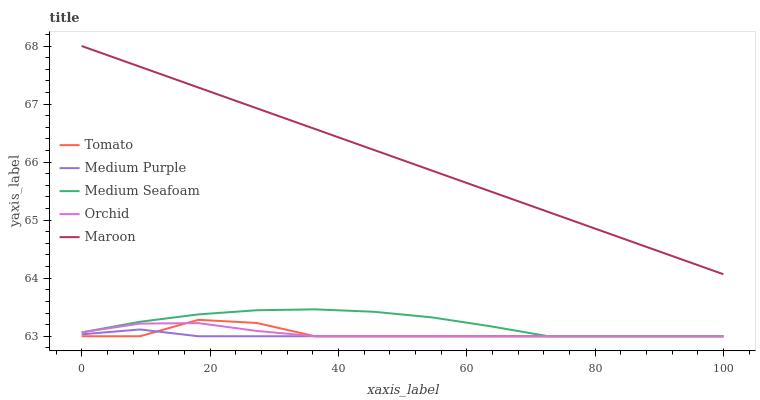Does Medium Seafoam have the minimum area under the curve?
Answer yes or no. No. Does Medium Seafoam have the maximum area under the curve?
Answer yes or no. No. Is Medium Purple the smoothest?
Answer yes or no. No. Is Medium Purple the roughest?
Answer yes or no. No. Does Maroon have the lowest value?
Answer yes or no. No. Does Medium Seafoam have the highest value?
Answer yes or no. No. Is Medium Seafoam less than Maroon?
Answer yes or no. Yes. Is Maroon greater than Medium Purple?
Answer yes or no. Yes. Does Medium Seafoam intersect Maroon?
Answer yes or no. No. 